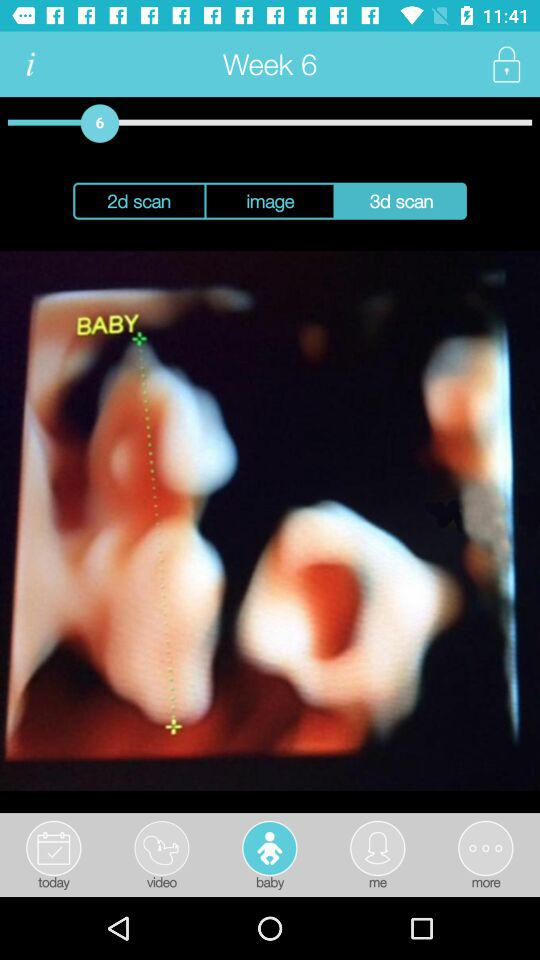What week of the baby being scanned? The week is 6. 